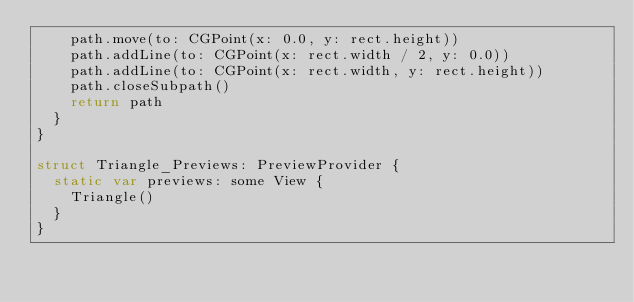<code> <loc_0><loc_0><loc_500><loc_500><_Swift_>    path.move(to: CGPoint(x: 0.0, y: rect.height))
    path.addLine(to: CGPoint(x: rect.width / 2, y: 0.0))
    path.addLine(to: CGPoint(x: rect.width, y: rect.height))
    path.closeSubpath()
    return path
  }
}

struct Triangle_Previews: PreviewProvider {
  static var previews: some View {
    Triangle()
  }
}
</code> 